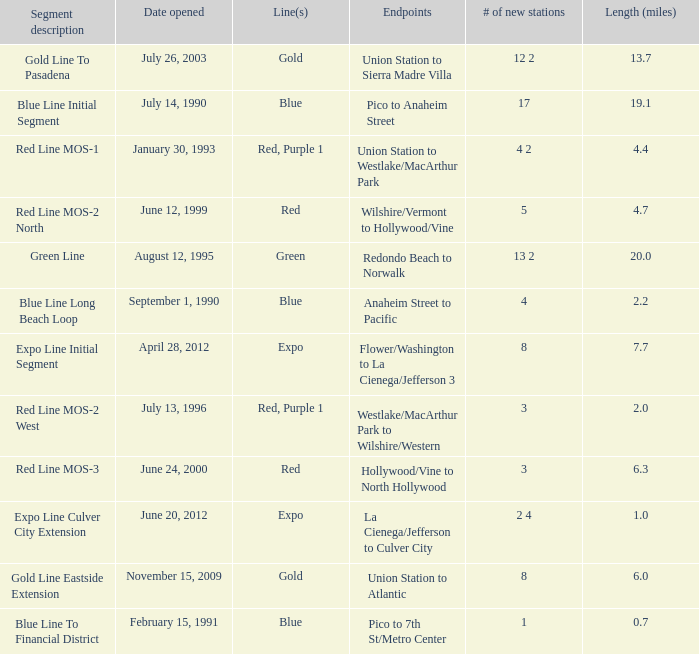How many news stations opened on the date of June 24, 2000? 3.0. 